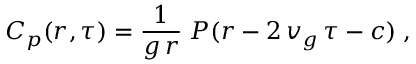Convert formula to latex. <formula><loc_0><loc_0><loc_500><loc_500>C _ { p } ( r , \tau ) = \frac { 1 } g \, r } \, P ( r - 2 \, v _ { g } \, \tau - c ) \, ,</formula> 